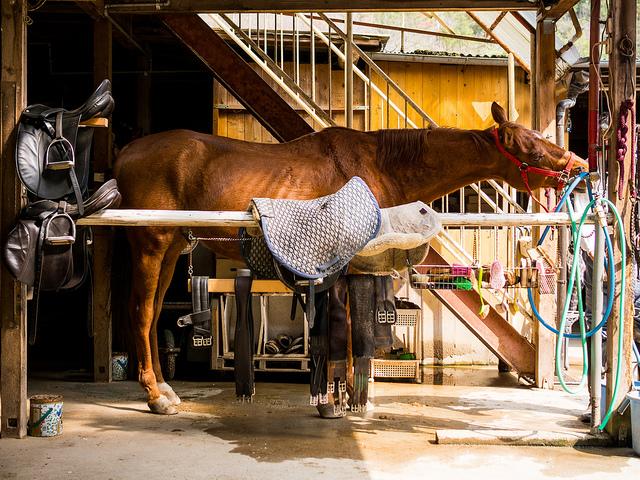How many saddles are there?
Give a very brief answer. 2. Is this horse in a stable?
Be succinct. Yes. Is the horse sleeping?
Keep it brief. No. 